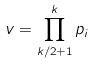<formula> <loc_0><loc_0><loc_500><loc_500>v = \prod _ { k / 2 + 1 } ^ { k } p _ { i }</formula> 